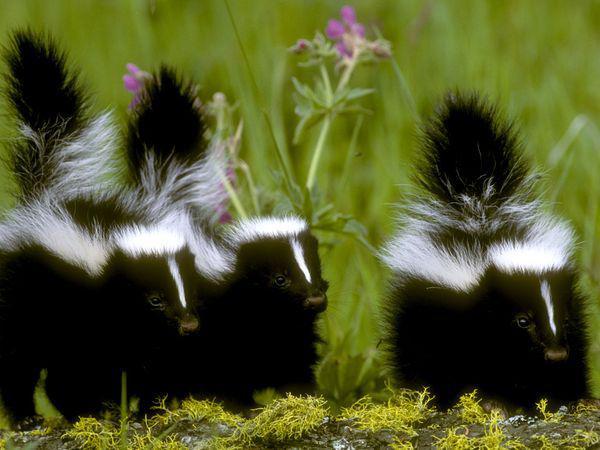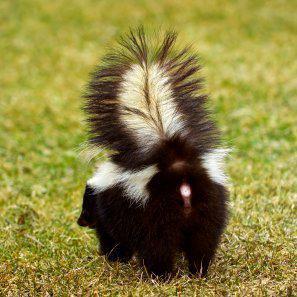The first image is the image on the left, the second image is the image on the right. Analyze the images presented: Is the assertion "There is a single skunk in the right image." valid? Answer yes or no. Yes. The first image is the image on the left, the second image is the image on the right. Assess this claim about the two images: "There are no more than four skunks in total.". Correct or not? Answer yes or no. Yes. 